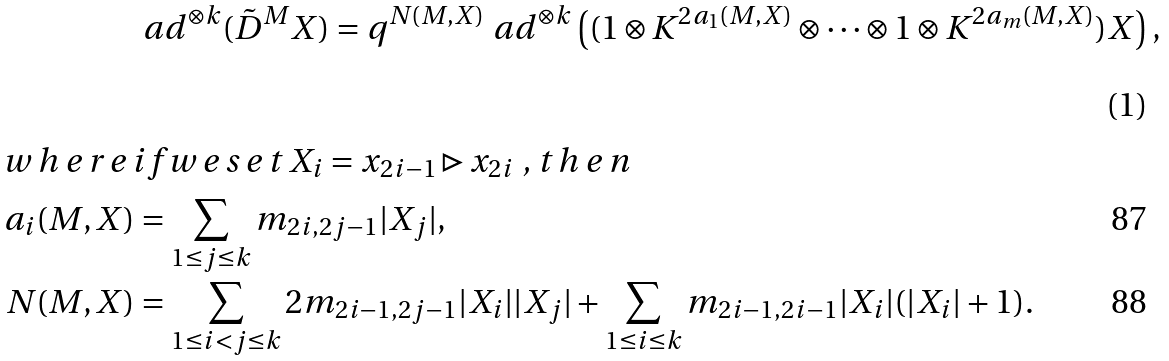<formula> <loc_0><loc_0><loc_500><loc_500>& \ a d ^ { \otimes k } ( \tilde { D } ^ { M } X ) = q ^ { N ( M , X ) } \ a d ^ { \otimes k } \left ( ( 1 \otimes K ^ { 2 a _ { 1 } ( M , X ) } \otimes \cdots \otimes 1 \otimes K ^ { 2 a _ { m } ( M , X ) } ) X \right ) , \intertext { w h e r e i f w e s e t $ X _ { i } = x _ { 2 i - 1 } \triangleright x _ { 2 i } $ , t h e n } a _ { i } ( M , X ) & = \sum _ { 1 \leq j \leq k } m _ { 2 i , 2 j - 1 } | X _ { j } | , \\ N ( M , X ) & = \sum _ { 1 \leq i < j \leq k } 2 m _ { 2 i - 1 , 2 j - 1 } | X _ { i } | | X _ { j } | + \sum _ { 1 \leq i \leq k } m _ { 2 i - 1 , 2 i - 1 } | X _ { i } | ( | X _ { i } | + 1 ) .</formula> 